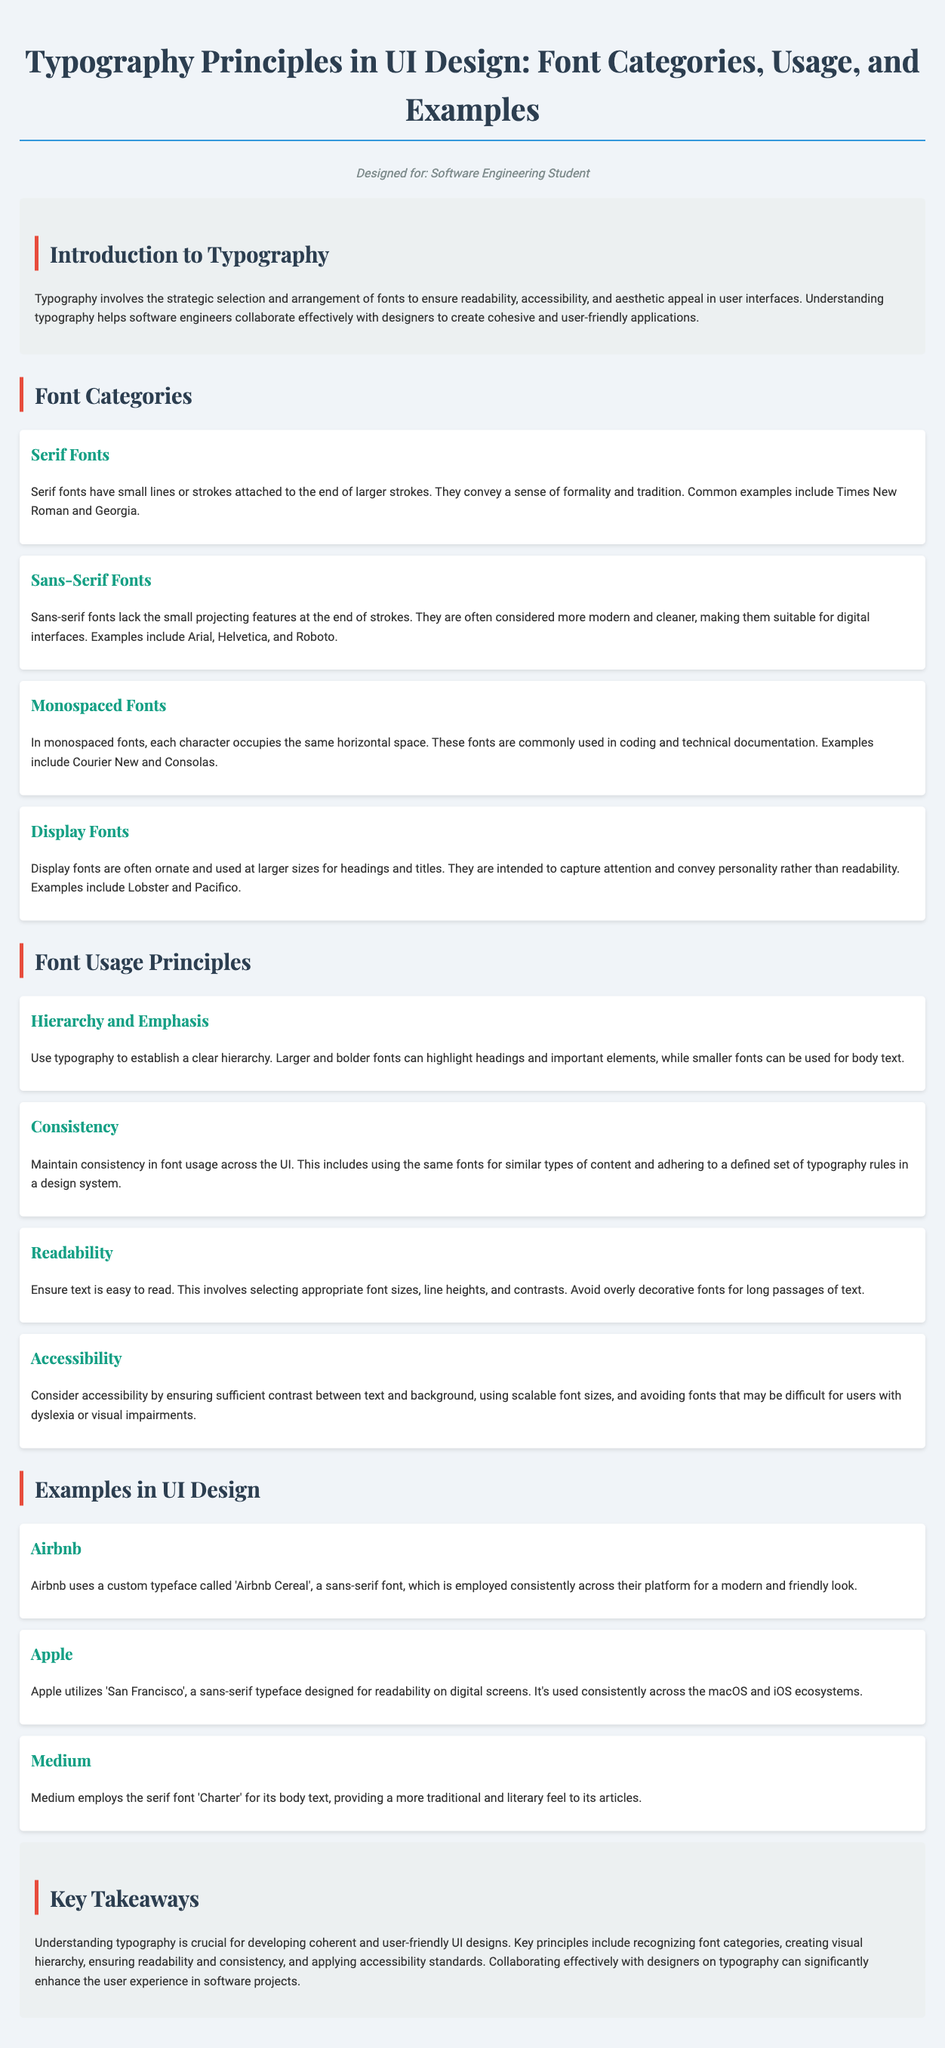What are the four font categories mentioned? The document lists four font categories: Serif, Sans-Serif, Monospaced, and Display.
Answer: Serif, Sans-Serif, Monospaced, Display What is the purpose of typography in UI design? Typography involves the strategic selection and arrangement of fonts to ensure readability, accessibility, and aesthetic appeal in user interfaces.
Answer: Readability, accessibility, and aesthetic appeal Which font is used by Airbnb? Airbnb uses a custom typeface called 'Airbnb Cereal'.
Answer: Airbnb Cereal What is one principle of font usage? The document states that one principle of font usage is hierarchy and emphasis.
Answer: Hierarchy and emphasis What font type does Medium use for its body text? Medium employs the serif font 'Charter' for its body text.
Answer: Charter Which key takeaway emphasizes collaboration with designers? Understanding typography is crucial for developing coherent and user-friendly UI designs, including collaboration with designers on typography.
Answer: Collaboration with designers How can typography impact user experience? Typography can significantly enhance the user experience in software projects through proper application of design principles.
Answer: Enhance user experience What is the font family used for headings? The font family used for headings is 'Playfair Display'.
Answer: Playfair Display 